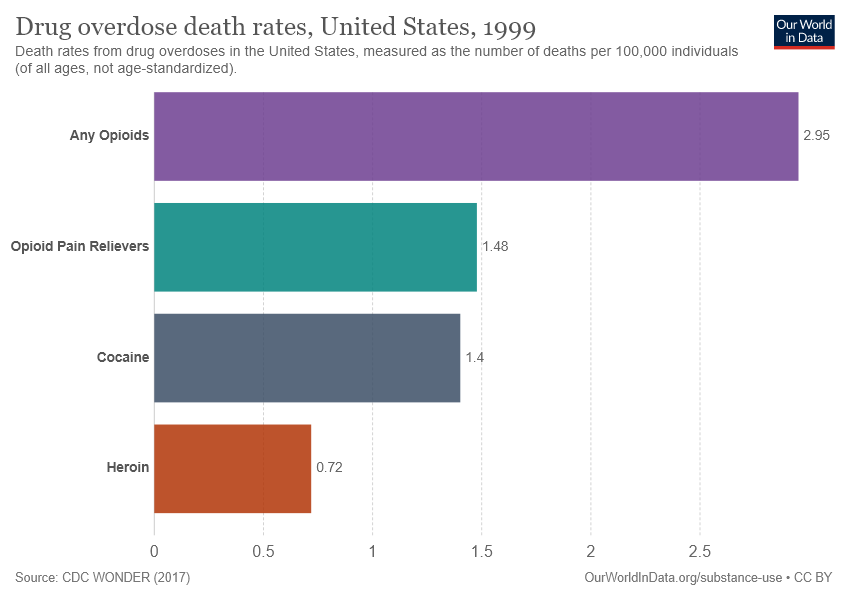Specify some key components in this picture. The sum of the smallest two bars is greater than the value of the second largest bar. The value of the smallest bar is 0.72. 